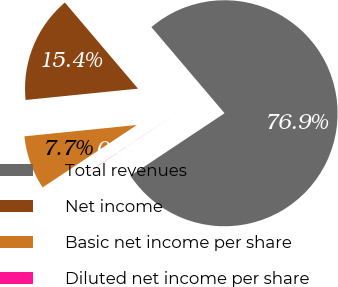<chart> <loc_0><loc_0><loc_500><loc_500><pie_chart><fcel>Total revenues<fcel>Net income<fcel>Basic net income per share<fcel>Diluted net income per share<nl><fcel>76.87%<fcel>15.39%<fcel>7.71%<fcel>0.03%<nl></chart> 